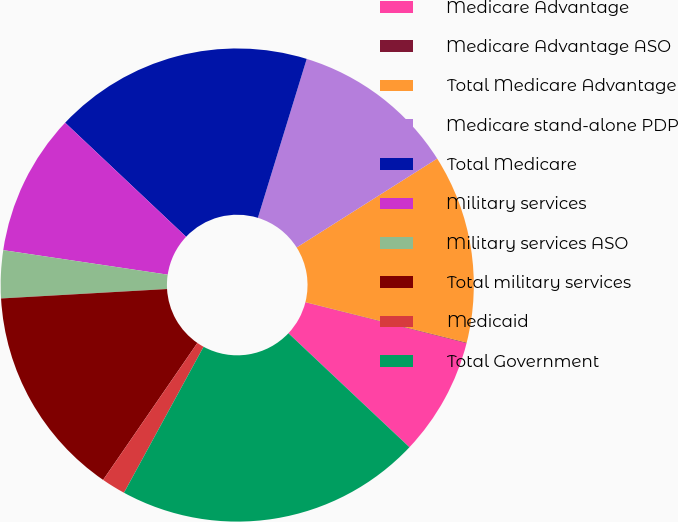<chart> <loc_0><loc_0><loc_500><loc_500><pie_chart><fcel>Medicare Advantage<fcel>Medicare Advantage ASO<fcel>Total Medicare Advantage<fcel>Medicare stand-alone PDP<fcel>Total Medicare<fcel>Military services<fcel>Military services ASO<fcel>Total military services<fcel>Medicaid<fcel>Total Government<nl><fcel>8.07%<fcel>0.04%<fcel>12.89%<fcel>11.28%<fcel>17.71%<fcel>9.68%<fcel>3.26%<fcel>14.5%<fcel>1.65%<fcel>20.92%<nl></chart> 